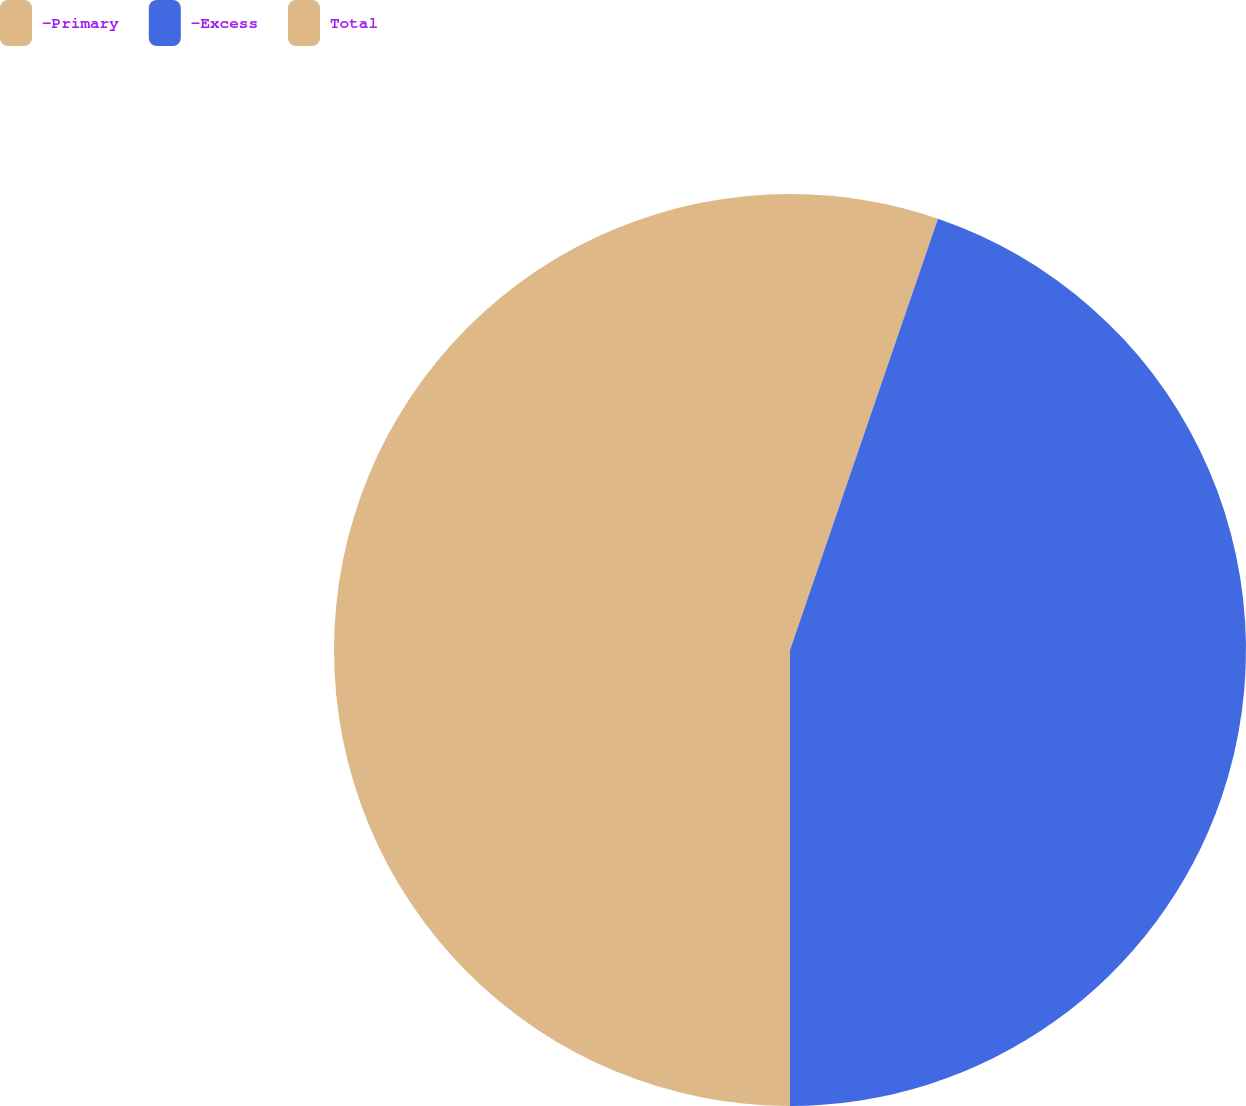Convert chart. <chart><loc_0><loc_0><loc_500><loc_500><pie_chart><fcel>-Primary<fcel>-Excess<fcel>Total<nl><fcel>5.26%<fcel>44.74%<fcel>50.0%<nl></chart> 